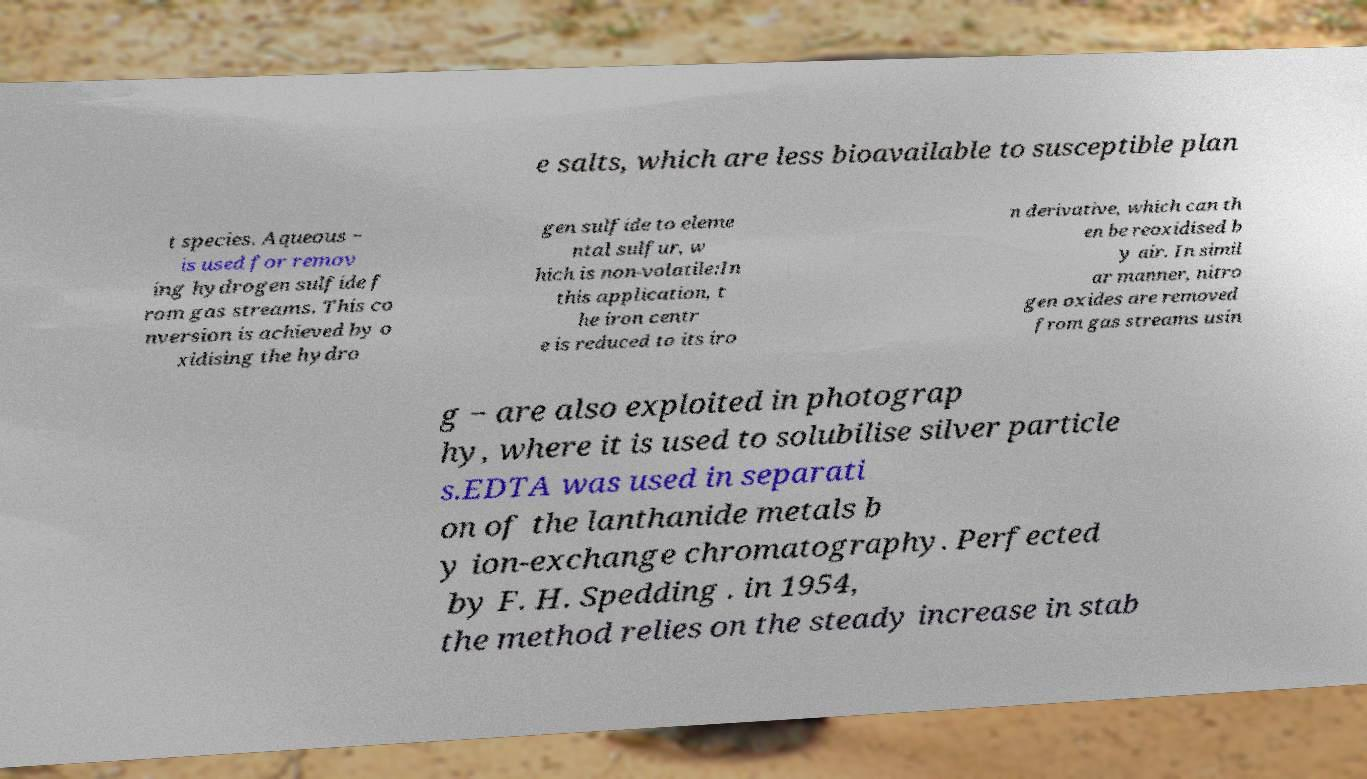For documentation purposes, I need the text within this image transcribed. Could you provide that? e salts, which are less bioavailable to susceptible plan t species. Aqueous − is used for remov ing hydrogen sulfide f rom gas streams. This co nversion is achieved by o xidising the hydro gen sulfide to eleme ntal sulfur, w hich is non-volatile:In this application, t he iron centr e is reduced to its iro n derivative, which can th en be reoxidised b y air. In simil ar manner, nitro gen oxides are removed from gas streams usin g − are also exploited in photograp hy, where it is used to solubilise silver particle s.EDTA was used in separati on of the lanthanide metals b y ion-exchange chromatography. Perfected by F. H. Spedding . in 1954, the method relies on the steady increase in stab 